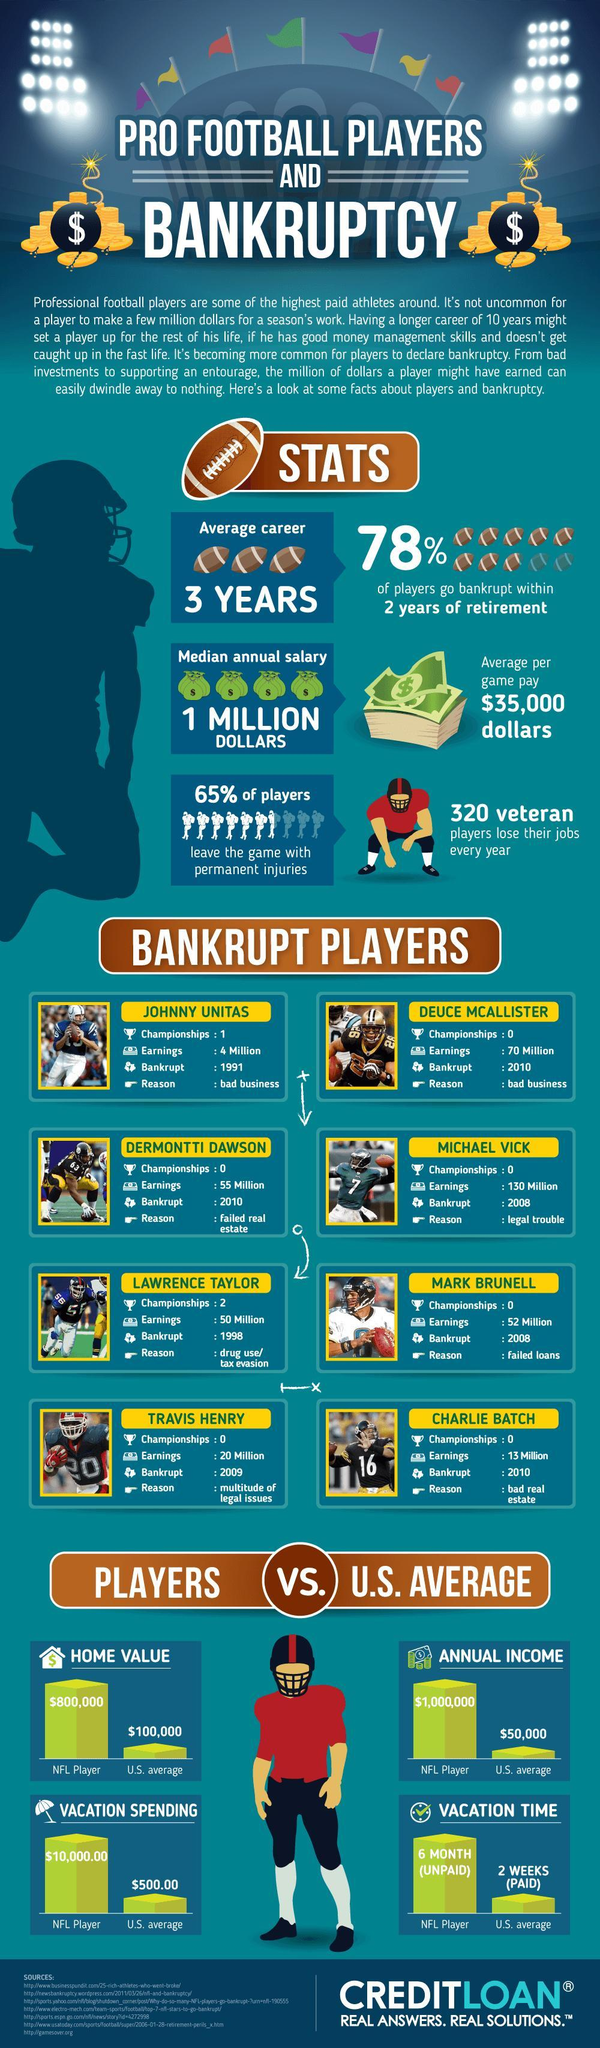What was the earning of Charlie Batch?
Answer the question with a short phrase. 13 Million What is the median annual salary of an NFL player? 1 MILLION DOLLARS How many NFL championship games were played by Johnny Unitas? 1 What is the reason for the bankruptcy of Mark Brunell? failed loans What is the annual income of an NFL player? $1,000,000 What was the earning of Michael Vick? 130 Million How much money is spend on vacation by an NFL player? $10,000.00 Which NFL player was bankrupt due to drug use or tax evasion among the pro football players? LAWRENCE TAYLOR What is the average unpaid vacation time spend by an NFL player? 6 MONTH 